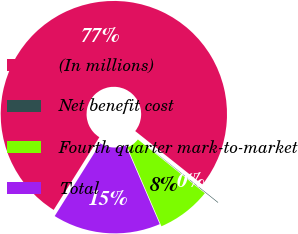<chart> <loc_0><loc_0><loc_500><loc_500><pie_chart><fcel>(In millions)<fcel>Net benefit cost<fcel>Fourth quarter mark-to-market<fcel>Total<nl><fcel>76.76%<fcel>0.08%<fcel>7.75%<fcel>15.41%<nl></chart> 